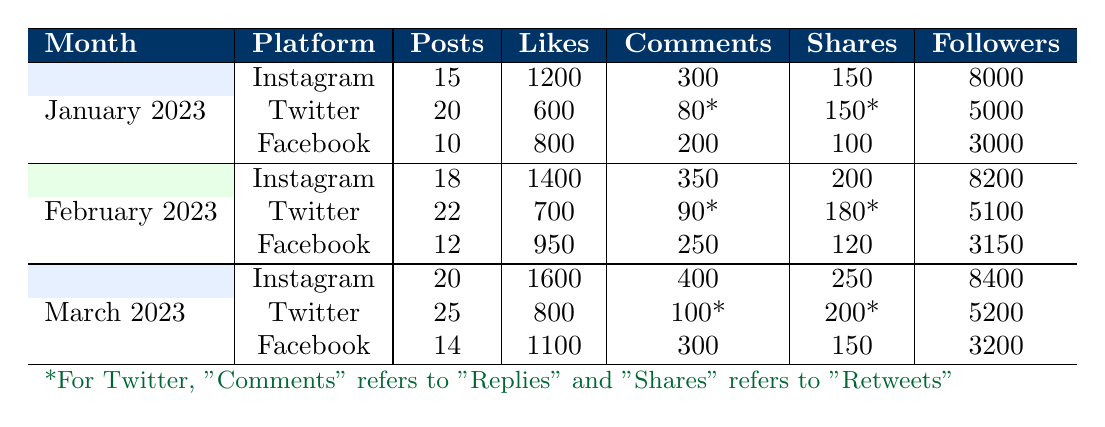What platform had the most posts in January 2023? In January 2023, the platforms and their respective post counts are: Instagram (15), Twitter (20), and Facebook (10). Comparing these values, Twitter had the highest number of posts.
Answer: Twitter What was the total number of likes earned on Instagram in February 2023? In February 2023, Instagram received 1400 likes. There are no other platforms considered for this question. Therefore, the total number of likes on Instagram in February is simply 1400.
Answer: 1400 Did the number of shares on Facebook increase from January to March 2023? From the table, the number of shares on Facebook in January 2023 was 100, and in March 2023 it was 150. Since 150 is greater than 100, it indicates an increase in shares.
Answer: Yes What is the average number of followers across all platforms in March 2023? In March 2023, the follower counts for each platform are: Instagram (8400), Twitter (5200), and Facebook (3200). To calculate the average, we sum these values: 8400 + 5200 + 3200 = 16800. Then, we divide by the number of platforms (3), yielding an average of 16800 / 3 = 5600.
Answer: 5600 Which month had the highest total number of likes across all platforms? We need to sum the likes for each month. For January: 1200 (Instagram) + 600 (Twitter) + 800 (Facebook) = 2600. For February: 1400 (Instagram) + 700 (Twitter) + 950 (Facebook) = 3050. For March: 1600 (Instagram) + 800 (Twitter) + 1100 (Facebook) = 3500. Comparing the totals, March had the highest total likes with 3500.
Answer: March 2023 